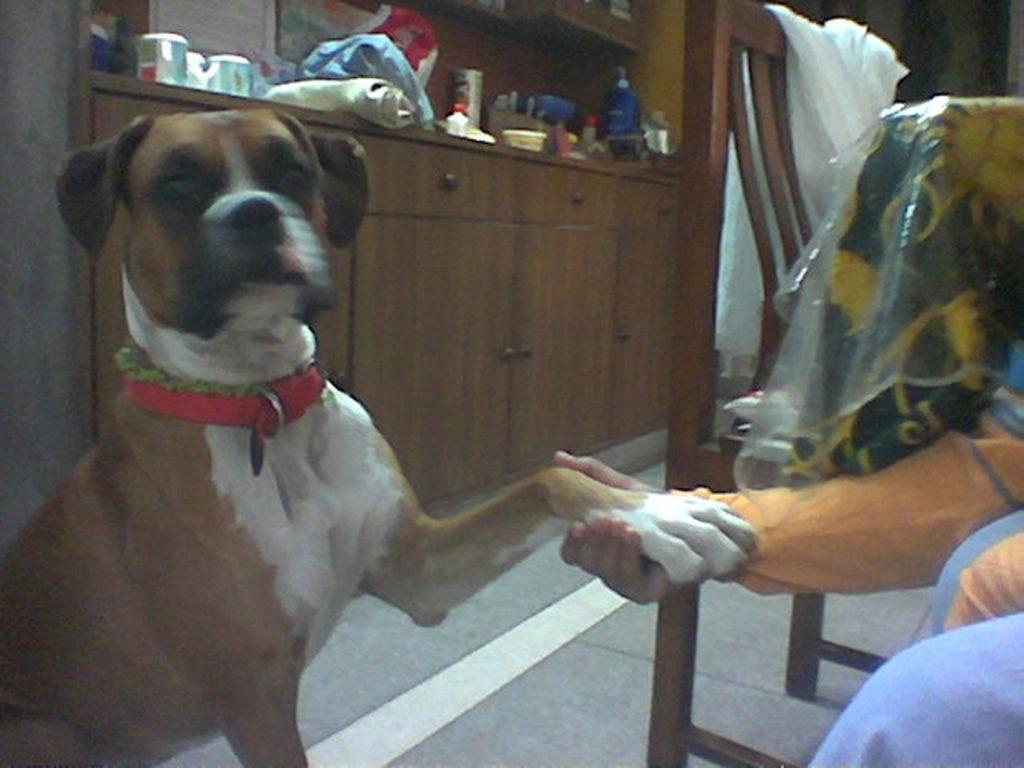What animal can be seen sitting on the floor in the image? There is a dog sitting on the floor in the image. What is the person in the image doing with the dog? The person is holding the dog's hand in the image. What type of furniture can be seen in the background of the image? There is a wardrobe made of wood in the background of the image. What type of sticks can be seen in the image? There are no sticks present in the image. What sound does the dog make in the image? The image is still, so it does not depict any sounds. 